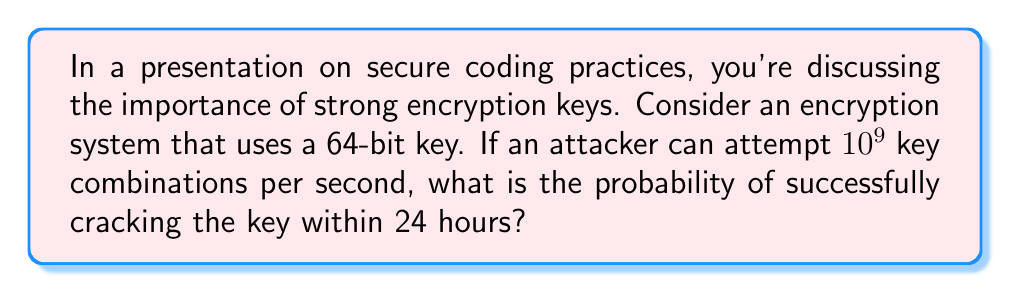Solve this math problem. Let's approach this step-by-step:

1) First, calculate the total number of possible keys:
   $$ \text{Total keys} = 2^{64} $$

2) Calculate how many attempts the attacker can make in 24 hours:
   $$ \text{Attempts per day} = 10^9 \times 60 \times 60 \times 24 = 8.64 \times 10^{13} $$

3) The probability of success is the number of attempts divided by the total number of possible keys:
   $$ P(\text{success}) = \frac{\text{Attempts per day}}{\text{Total keys}} = \frac{8.64 \times 10^{13}}{2^{64}} $$

4) Simplify:
   $$ P(\text{success}) = \frac{8.64 \times 10^{13}}{18,446,744,073,709,551,616} \approx 4.68 \times 10^{-6} $$

5) Convert to percentage:
   $$ P(\text{success}) \approx 4.68 \times 10^{-4}\% $$

This extremely low probability demonstrates the strength of a 64-bit key against brute-force attacks, emphasizing the importance of key length in secure coding practices.
Answer: $4.68 \times 10^{-4}\%$ 